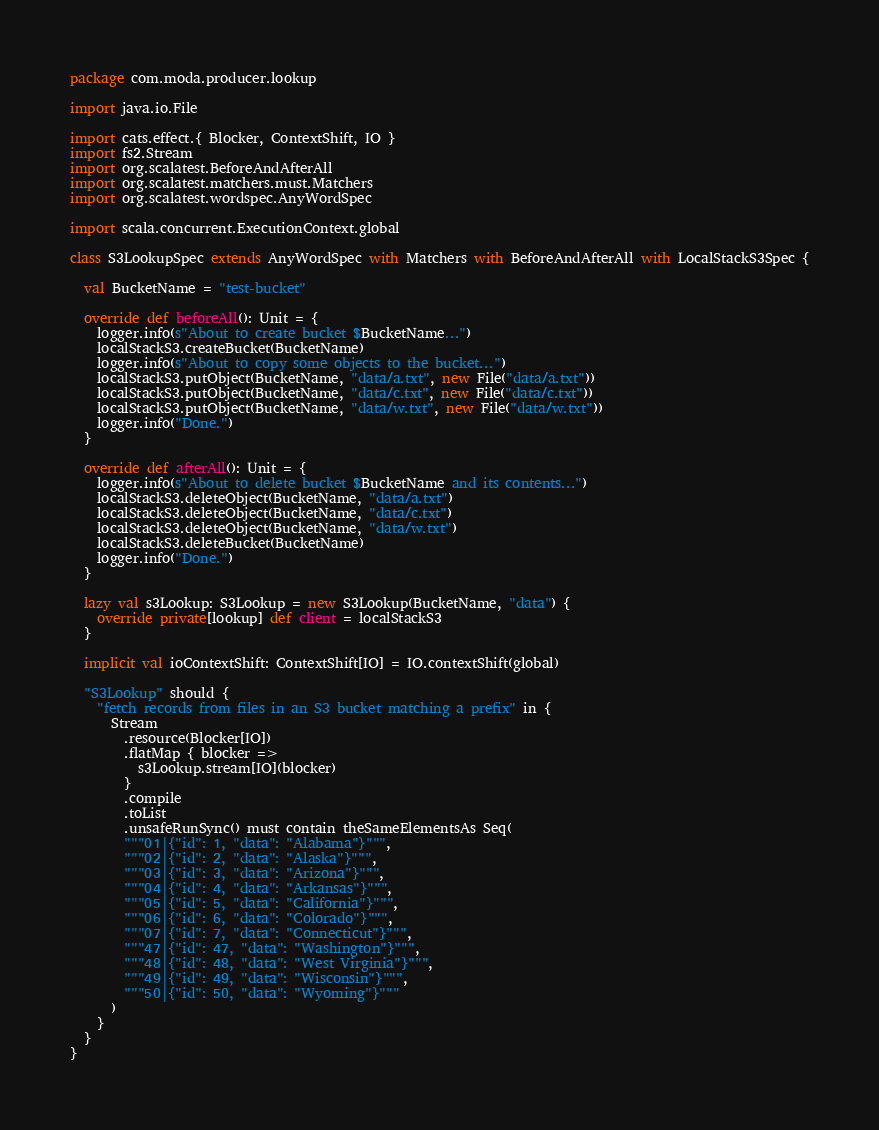Convert code to text. <code><loc_0><loc_0><loc_500><loc_500><_Scala_>package com.moda.producer.lookup

import java.io.File

import cats.effect.{ Blocker, ContextShift, IO }
import fs2.Stream
import org.scalatest.BeforeAndAfterAll
import org.scalatest.matchers.must.Matchers
import org.scalatest.wordspec.AnyWordSpec

import scala.concurrent.ExecutionContext.global

class S3LookupSpec extends AnyWordSpec with Matchers with BeforeAndAfterAll with LocalStackS3Spec {

  val BucketName = "test-bucket"

  override def beforeAll(): Unit = {
    logger.info(s"About to create bucket $BucketName...")
    localStackS3.createBucket(BucketName)
    logger.info(s"About to copy some objects to the bucket...")
    localStackS3.putObject(BucketName, "data/a.txt", new File("data/a.txt"))
    localStackS3.putObject(BucketName, "data/c.txt", new File("data/c.txt"))
    localStackS3.putObject(BucketName, "data/w.txt", new File("data/w.txt"))
    logger.info("Done.")
  }

  override def afterAll(): Unit = {
    logger.info(s"About to delete bucket $BucketName and its contents...")
    localStackS3.deleteObject(BucketName, "data/a.txt")
    localStackS3.deleteObject(BucketName, "data/c.txt")
    localStackS3.deleteObject(BucketName, "data/w.txt")
    localStackS3.deleteBucket(BucketName)
    logger.info("Done.")
  }

  lazy val s3Lookup: S3Lookup = new S3Lookup(BucketName, "data") {
    override private[lookup] def client = localStackS3
  }

  implicit val ioContextShift: ContextShift[IO] = IO.contextShift(global)

  "S3Lookup" should {
    "fetch records from files in an S3 bucket matching a prefix" in {
      Stream
        .resource(Blocker[IO])
        .flatMap { blocker =>
          s3Lookup.stream[IO](blocker)
        }
        .compile
        .toList
        .unsafeRunSync() must contain theSameElementsAs Seq(
        """01|{"id": 1, "data": "Alabama"}""",
        """02|{"id": 2, "data": "Alaska"}""",
        """03|{"id": 3, "data": "Arizona"}""",
        """04|{"id": 4, "data": "Arkansas"}""",
        """05|{"id": 5, "data": "California"}""",
        """06|{"id": 6, "data": "Colorado"}""",
        """07|{"id": 7, "data": "Connecticut"}""",
        """47|{"id": 47, "data": "Washington"}""",
        """48|{"id": 48, "data": "West Virginia"}""",
        """49|{"id": 49, "data": "Wisconsin"}""",
        """50|{"id": 50, "data": "Wyoming"}"""
      )
    }
  }
}
</code> 